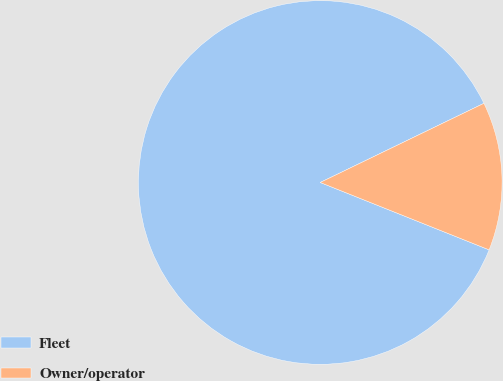<chart> <loc_0><loc_0><loc_500><loc_500><pie_chart><fcel>Fleet<fcel>Owner/operator<nl><fcel>86.79%<fcel>13.21%<nl></chart> 